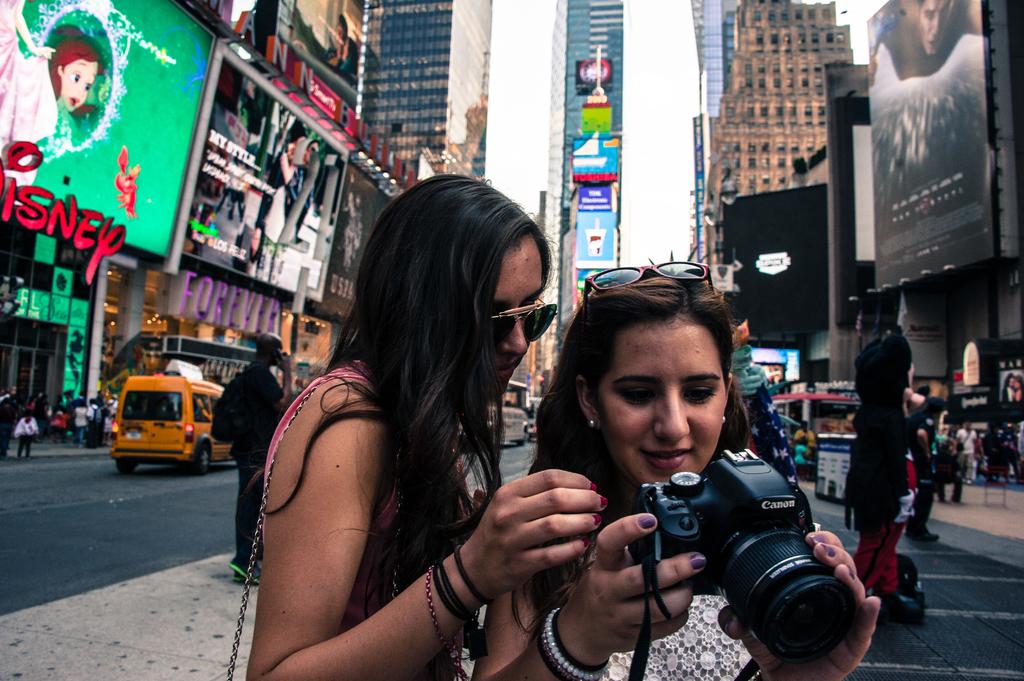What store is being them?
Your answer should be very brief. Disney. What brand of camera is the girl on the right holding?
Give a very brief answer. Canon. 